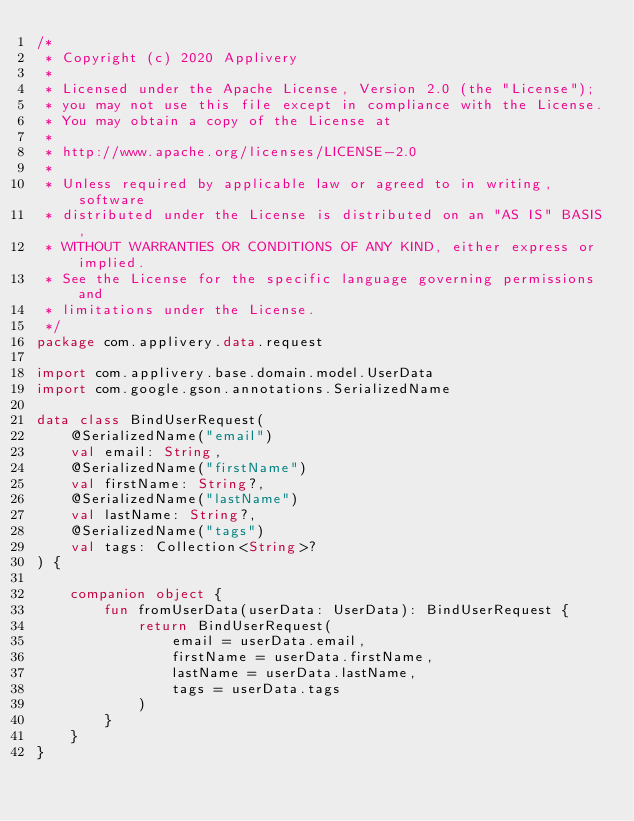<code> <loc_0><loc_0><loc_500><loc_500><_Kotlin_>/*
 * Copyright (c) 2020 Applivery
 *
 * Licensed under the Apache License, Version 2.0 (the "License");
 * you may not use this file except in compliance with the License.
 * You may obtain a copy of the License at
 *
 * http://www.apache.org/licenses/LICENSE-2.0
 *
 * Unless required by applicable law or agreed to in writing, software
 * distributed under the License is distributed on an "AS IS" BASIS,
 * WITHOUT WARRANTIES OR CONDITIONS OF ANY KIND, either express or implied.
 * See the License for the specific language governing permissions and
 * limitations under the License.
 */
package com.applivery.data.request

import com.applivery.base.domain.model.UserData
import com.google.gson.annotations.SerializedName

data class BindUserRequest(
    @SerializedName("email")
    val email: String,
    @SerializedName("firstName")
    val firstName: String?,
    @SerializedName("lastName")
    val lastName: String?,
    @SerializedName("tags")
    val tags: Collection<String>?
) {

    companion object {
        fun fromUserData(userData: UserData): BindUserRequest {
            return BindUserRequest(
                email = userData.email,
                firstName = userData.firstName,
                lastName = userData.lastName,
                tags = userData.tags
            )
        }
    }
}
</code> 